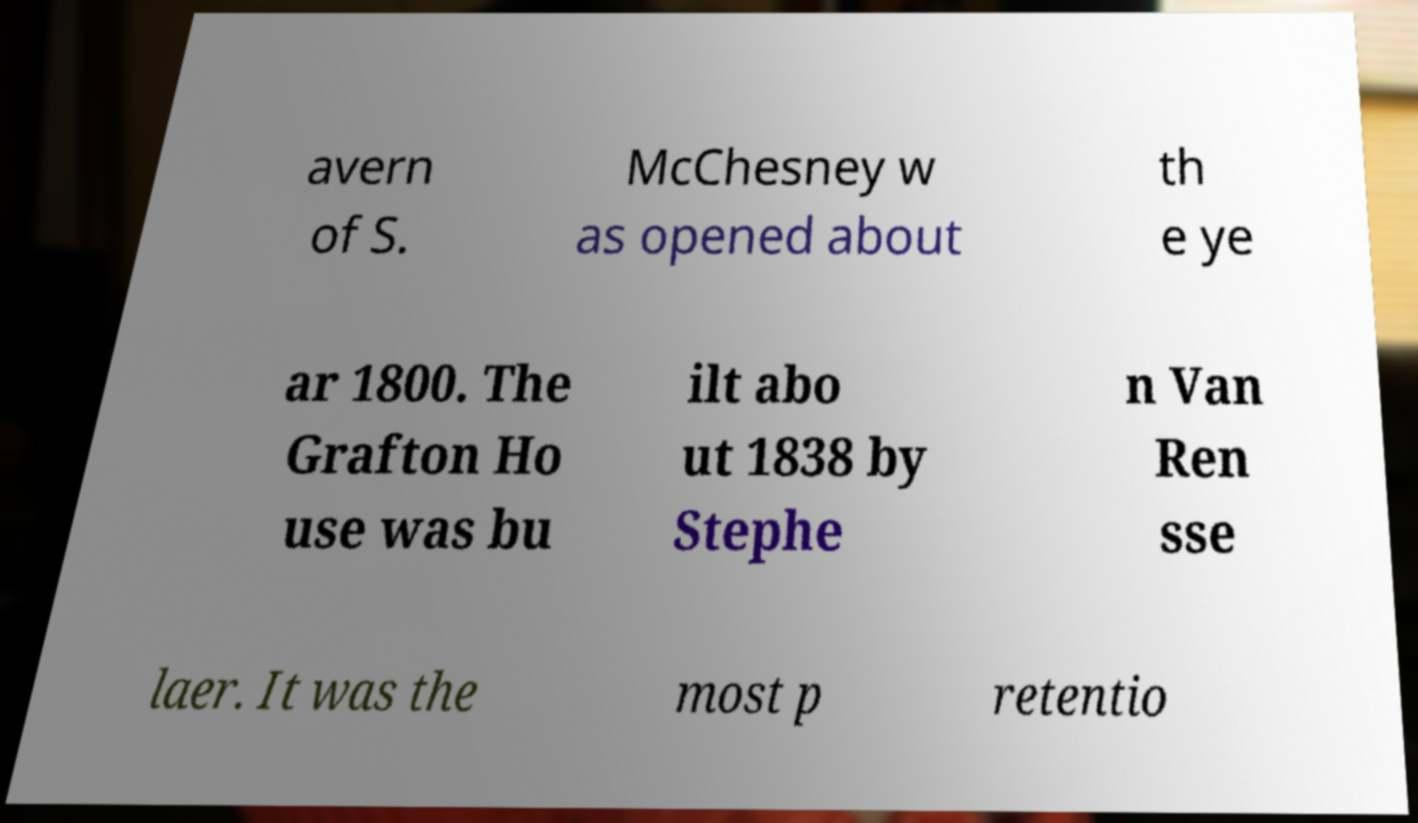Can you accurately transcribe the text from the provided image for me? avern of S. McChesney w as opened about th e ye ar 1800. The Grafton Ho use was bu ilt abo ut 1838 by Stephe n Van Ren sse laer. It was the most p retentio 